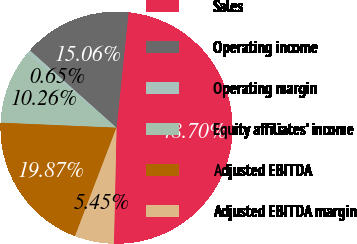Convert chart. <chart><loc_0><loc_0><loc_500><loc_500><pie_chart><fcel>Sales<fcel>Operating income<fcel>Operating margin<fcel>Equity affiliates' income<fcel>Adjusted EBITDA<fcel>Adjusted EBITDA margin<nl><fcel>48.7%<fcel>15.06%<fcel>0.65%<fcel>10.26%<fcel>19.87%<fcel>5.45%<nl></chart> 